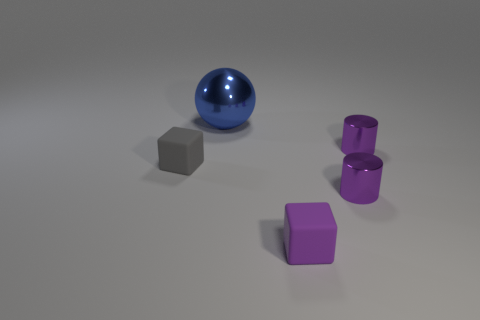Can you describe the shapes and colors of the objects in the image? Certainly! In the image, there is a collection of geometric shapes. These include a large blue sphere, a gray cube, and two purple cylindrical objects. Additionally, there is a smaller purple cube. The arrangement of the objects on a light surface gives off an almost studio-like ambiance with soft shadows cast by the objects. 